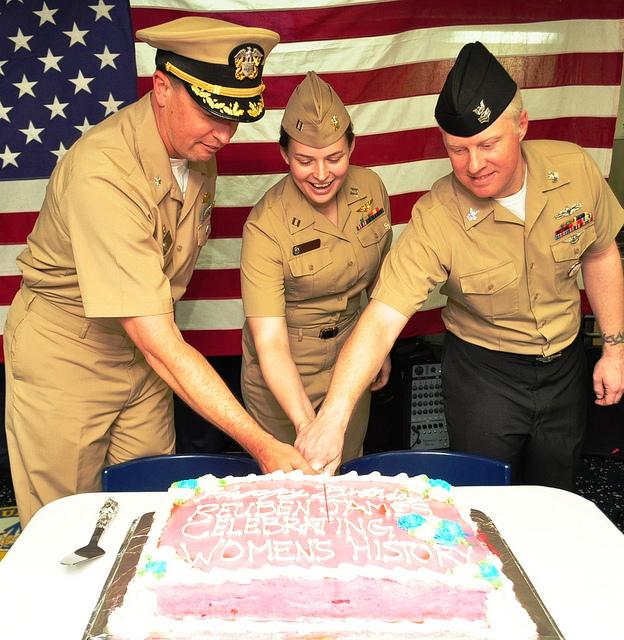What uniforms are shown?
Quick response, please. Military. Is this a celebration?
Quick response, please. Yes. How many people are shown?
Short answer required. 3. What is this man wearing on his head?
Be succinct. Hat. What is on the shirt?
Concise answer only. Medals. Is this an adult or a child's cake?
Give a very brief answer. Adult. 